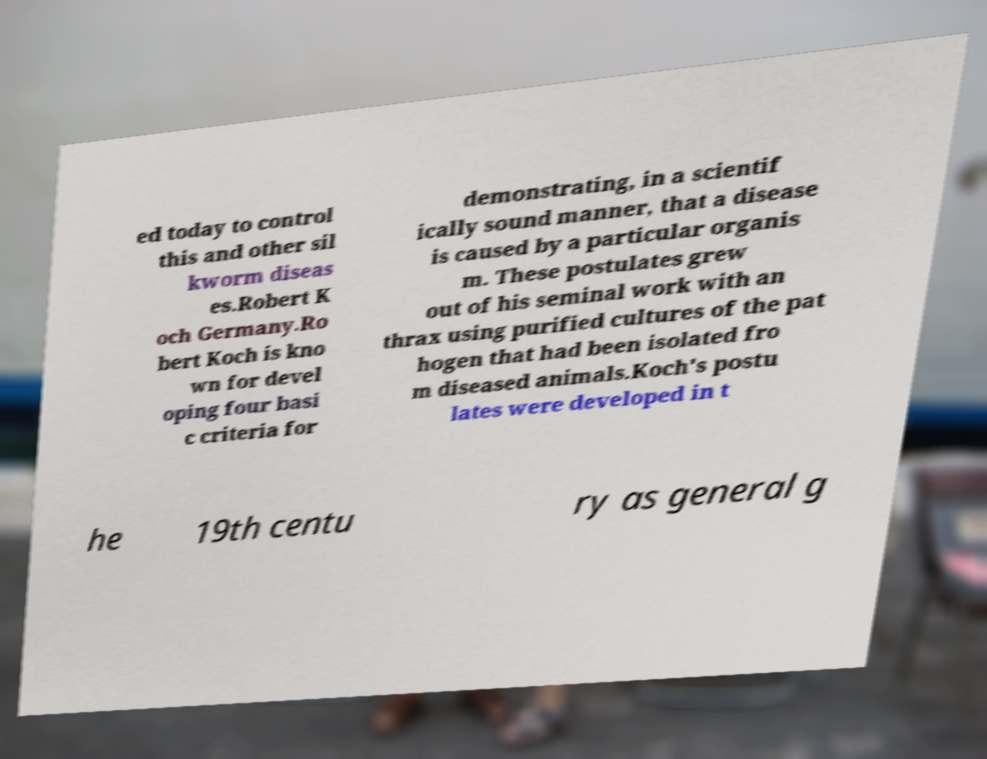What messages or text are displayed in this image? I need them in a readable, typed format. ed today to control this and other sil kworm diseas es.Robert K och Germany.Ro bert Koch is kno wn for devel oping four basi c criteria for demonstrating, in a scientif ically sound manner, that a disease is caused by a particular organis m. These postulates grew out of his seminal work with an thrax using purified cultures of the pat hogen that had been isolated fro m diseased animals.Koch's postu lates were developed in t he 19th centu ry as general g 